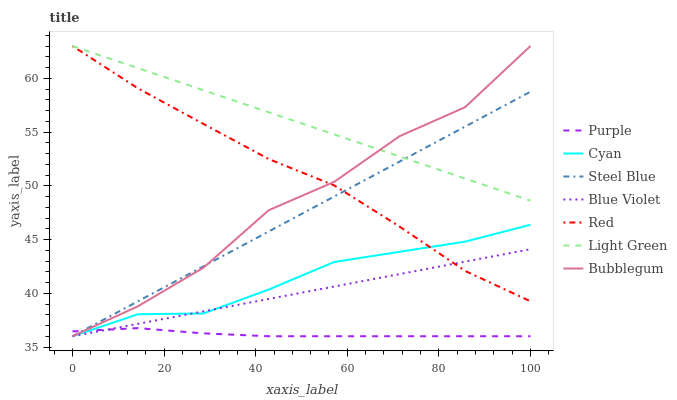Does Purple have the minimum area under the curve?
Answer yes or no. Yes. Does Light Green have the maximum area under the curve?
Answer yes or no. Yes. Does Steel Blue have the minimum area under the curve?
Answer yes or no. No. Does Steel Blue have the maximum area under the curve?
Answer yes or no. No. Is Light Green the smoothest?
Answer yes or no. Yes. Is Bubblegum the roughest?
Answer yes or no. Yes. Is Steel Blue the smoothest?
Answer yes or no. No. Is Steel Blue the roughest?
Answer yes or no. No. Does Purple have the lowest value?
Answer yes or no. Yes. Does Light Green have the lowest value?
Answer yes or no. No. Does Red have the highest value?
Answer yes or no. Yes. Does Steel Blue have the highest value?
Answer yes or no. No. Is Cyan less than Light Green?
Answer yes or no. Yes. Is Light Green greater than Cyan?
Answer yes or no. Yes. Does Cyan intersect Bubblegum?
Answer yes or no. Yes. Is Cyan less than Bubblegum?
Answer yes or no. No. Is Cyan greater than Bubblegum?
Answer yes or no. No. Does Cyan intersect Light Green?
Answer yes or no. No. 